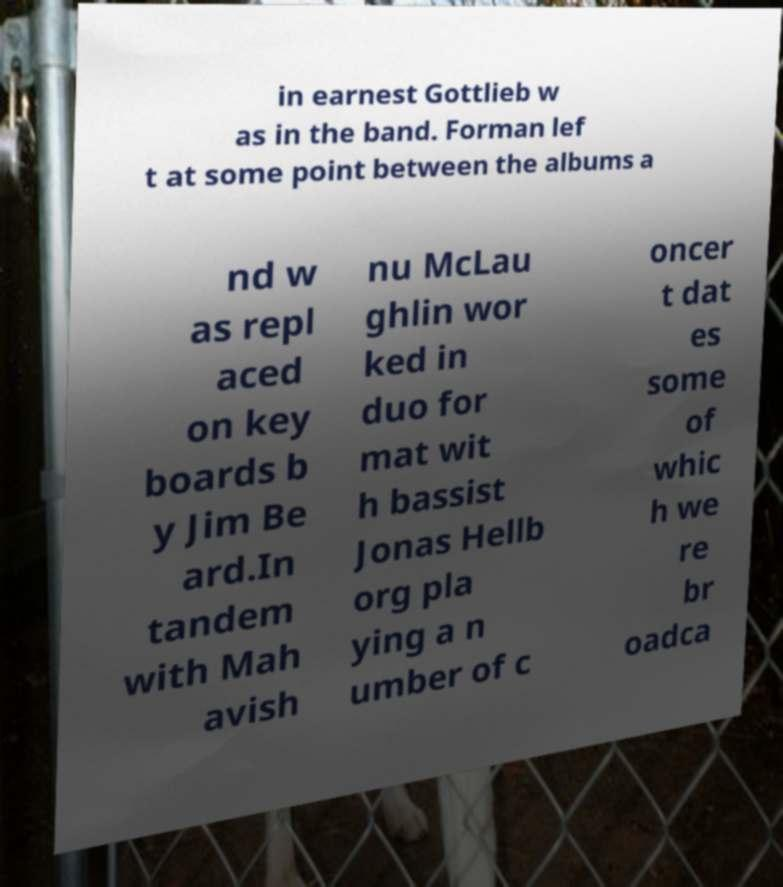What messages or text are displayed in this image? I need them in a readable, typed format. in earnest Gottlieb w as in the band. Forman lef t at some point between the albums a nd w as repl aced on key boards b y Jim Be ard.In tandem with Mah avish nu McLau ghlin wor ked in duo for mat wit h bassist Jonas Hellb org pla ying a n umber of c oncer t dat es some of whic h we re br oadca 